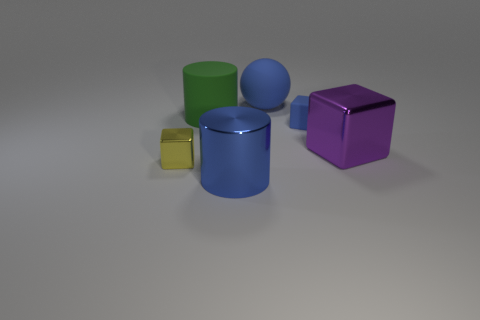How many cubes are either small objects or big blue rubber objects?
Your answer should be compact. 2. There is a tiny thing to the right of the big green object; is it the same color as the large rubber sphere?
Ensure brevity in your answer.  Yes. What is the block that is on the left side of the large blue thing in front of the metallic object that is right of the large blue metal cylinder made of?
Your answer should be very brief. Metal. Is the size of the sphere the same as the purple metal block?
Make the answer very short. Yes. There is a large rubber sphere; is it the same color as the large metal object in front of the big purple block?
Ensure brevity in your answer.  Yes. What is the shape of the purple thing that is made of the same material as the small yellow cube?
Offer a terse response. Cube. Do the large blue thing that is in front of the big block and the yellow metallic thing have the same shape?
Ensure brevity in your answer.  No. What size is the metallic thing that is right of the small block that is right of the yellow object?
Ensure brevity in your answer.  Large. What color is the other large block that is the same material as the yellow block?
Ensure brevity in your answer.  Purple. What number of blue cylinders have the same size as the blue cube?
Your answer should be compact. 0. 